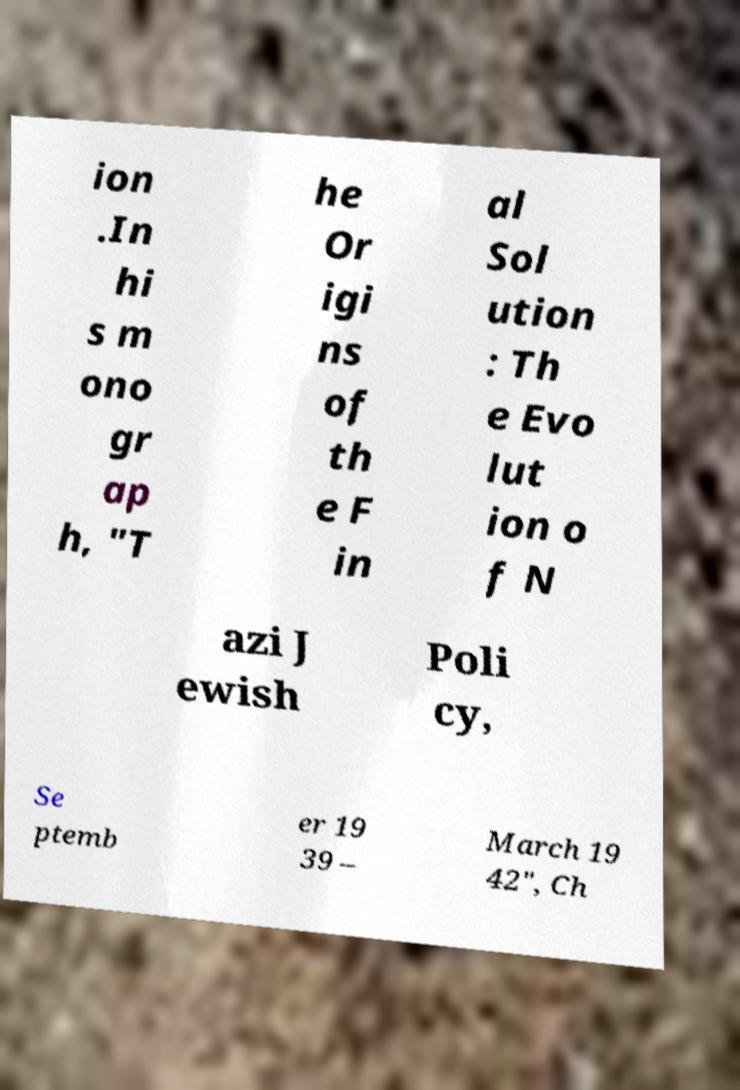Could you assist in decoding the text presented in this image and type it out clearly? ion .In hi s m ono gr ap h, "T he Or igi ns of th e F in al Sol ution : Th e Evo lut ion o f N azi J ewish Poli cy, Se ptemb er 19 39 – March 19 42", Ch 